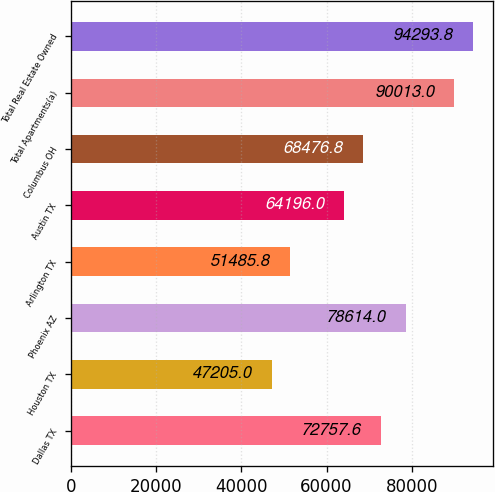<chart> <loc_0><loc_0><loc_500><loc_500><bar_chart><fcel>Dallas TX<fcel>Houston TX<fcel>Phoenix AZ<fcel>Arlington TX<fcel>Austin TX<fcel>Columbus OH<fcel>Total Apartments(a)<fcel>Total Real Estate Owned<nl><fcel>72757.6<fcel>47205<fcel>78614<fcel>51485.8<fcel>64196<fcel>68476.8<fcel>90013<fcel>94293.8<nl></chart> 